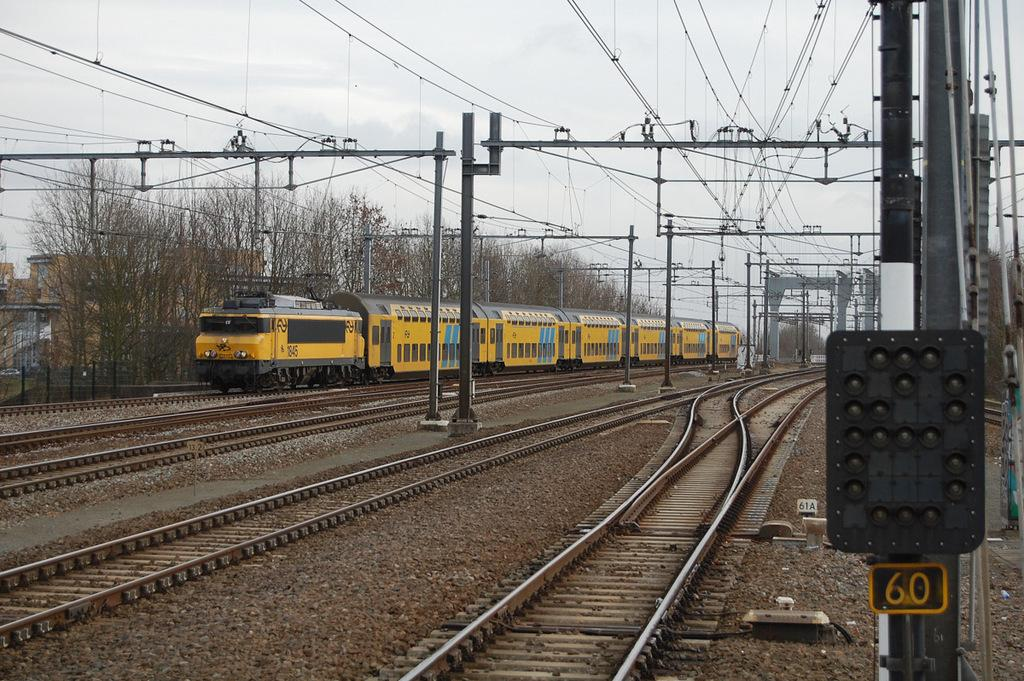What type of vehicle is in the image? There is an electric train in the image. Where is the train located? The train is on a railway track. What can be seen on the right side of the image? There are poles on the right side of the image. What is visible in the background of the image? There are trees and buildings in the background of the image. Who is the creator of the twig seen in the image? There is no twig present in the image, so it is not possible to determine the creator. 